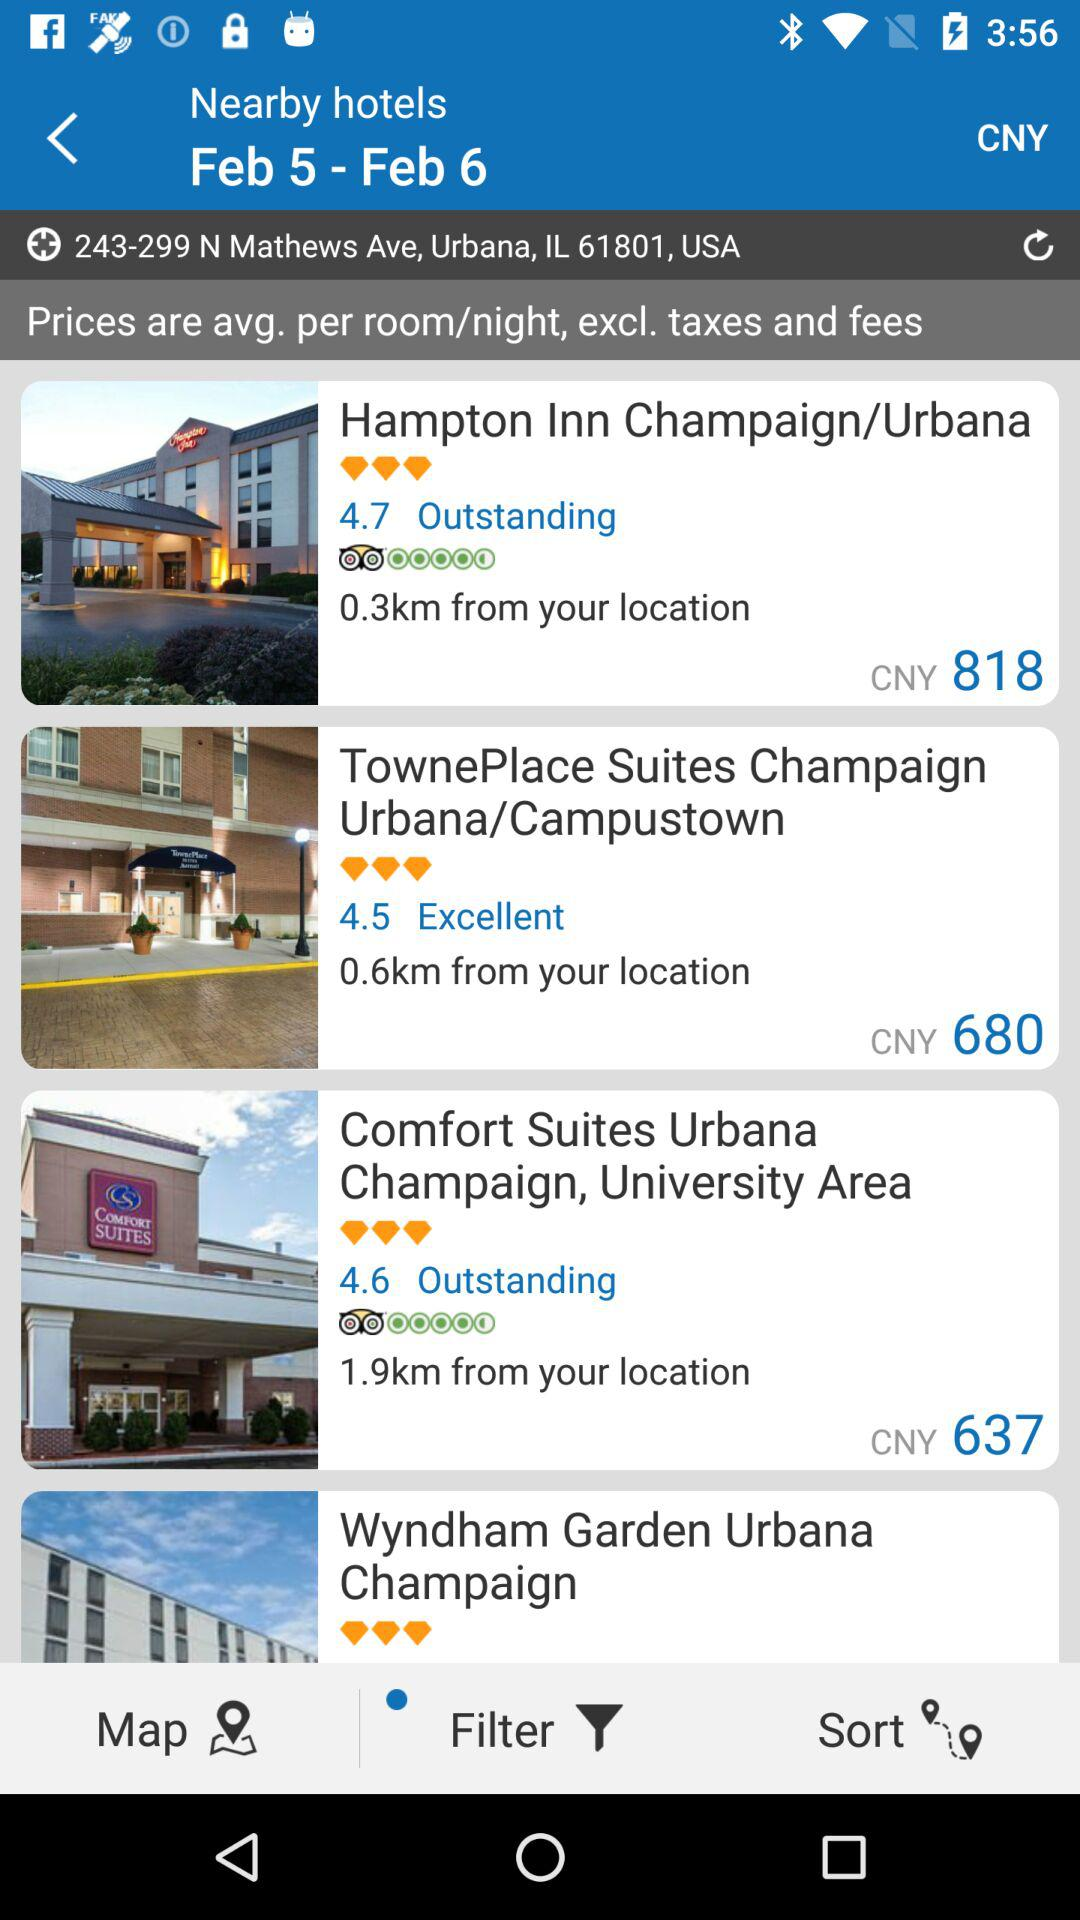What is the average price per room for the Comfort Suites Urbana Champaign, University Area? The average price per room is CNY 637. 